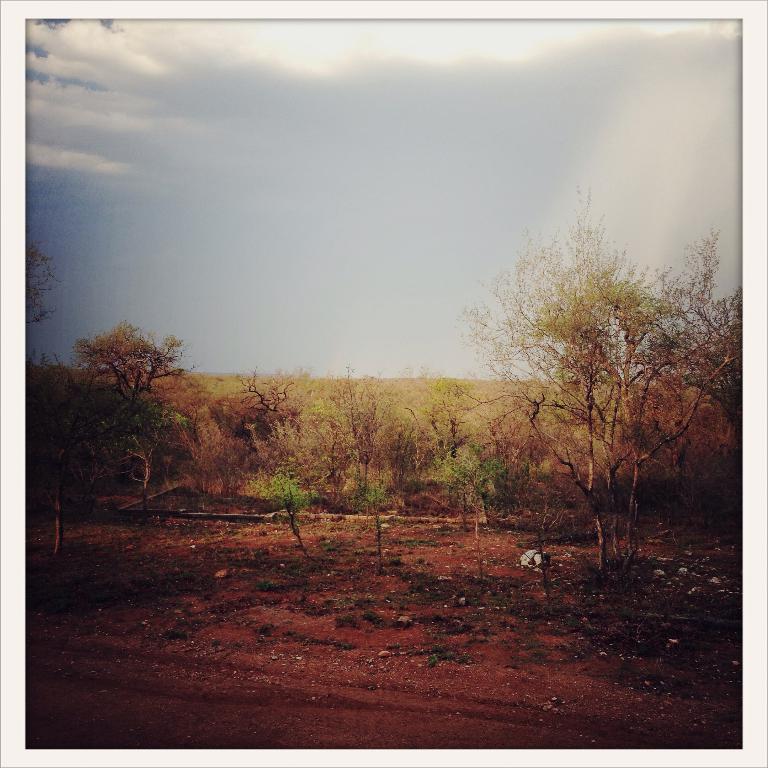In one or two sentences, can you explain what this image depicts? In this picture we can see the grass, stones on the ground, trees and in the background we can see the sky with clouds. 